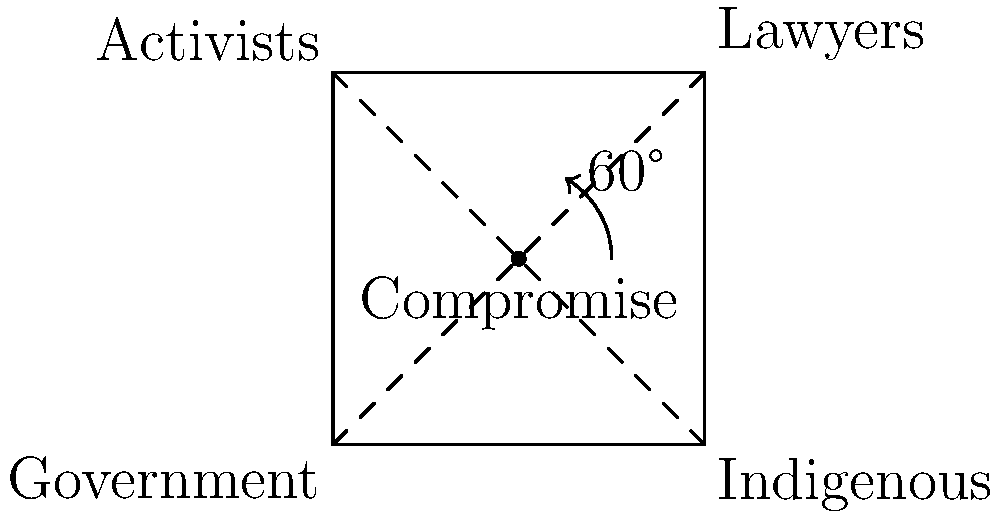In a complex negotiation involving indigenous rights, different stakeholder groups are represented by a square ABCD, where A represents the government, B represents indigenous groups, C represents lawyers, and D represents activists. The point of compromise E is at the center of the square. If the square is rotated 60° clockwise around point E, what will be the new position of point A in relation to the original square? To solve this problem, we need to follow these steps:

1) First, we need to understand that rotating a point around another point by an angle $\theta$ can be achieved using the following transformation:
   $x' = (x - x_c)\cos\theta - (y - y_c)\sin\theta + x_c$
   $y' = (x - x_c)\sin\theta + (y - y_c)\cos\theta + y_c$
   Where $(x,y)$ is the original point, $(x_c,y_c)$ is the center of rotation, and $(x',y')$ is the new point.

2) In this case, we're rotating 60° clockwise, which is equivalent to rotating -60° counterclockwise. We'll use $\theta = -60°$ or $-\frac{\pi}{3}$ radians.

3) The center of rotation E is at (1,1), so $x_c = 1$ and $y_c = 1$.

4) Point A is at (0,0), so $x = 0$ and $y = 0$.

5) Plugging these into our equations:
   $x' = (0 - 1)\cos(-\frac{\pi}{3}) - (0 - 1)\sin(-\frac{\pi}{3}) + 1$
   $y' = (0 - 1)\sin(-\frac{\pi}{3}) + (0 - 1)\cos(-\frac{\pi}{3}) + 1$

6) Simplifying:
   $x' = -\frac{1}{2} + \frac{\sqrt{3}}{2} + 1 = \frac{1}{2} + \frac{\sqrt{3}}{2}$
   $y' = -\frac{\sqrt{3}}{2} - \frac{1}{2} + 1 = \frac{1}{2} - \frac{\sqrt{3}}{2}$

7) This new point $(x',y')$ is located on the line BD of the original square.

Therefore, after rotation, point A will be on the diagonal BD of the original square, closer to point B.
Answer: On diagonal BD, closer to B 